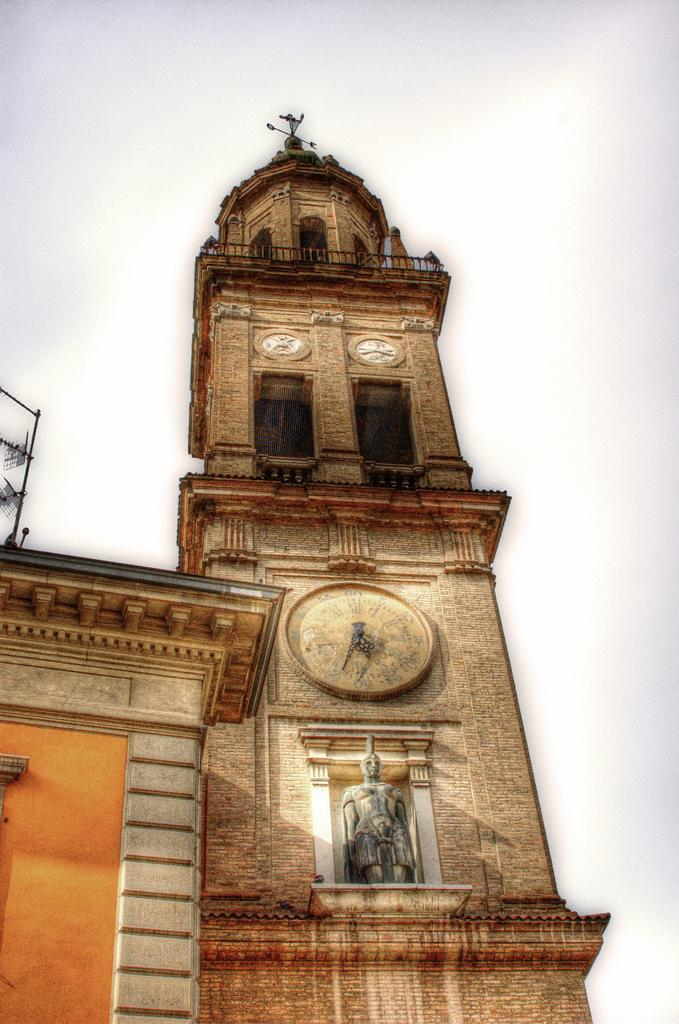How many buildings can be seen in the image? There are two buildings in the image. What other object is present in the image besides the buildings? There is a statue in the image. What feature can be seen on one of the buildings? There are clocks on one of the buildings. What color is the background of the image? The background of the image is white. What type of apparel is the statue wearing in the image? There is no apparel visible on the statue in the image, as it is a statue and not a person. Can you describe the alley where the buildings are located in the image? There is no alley present in the image; the buildings and statue are situated in an open area with a white background. 